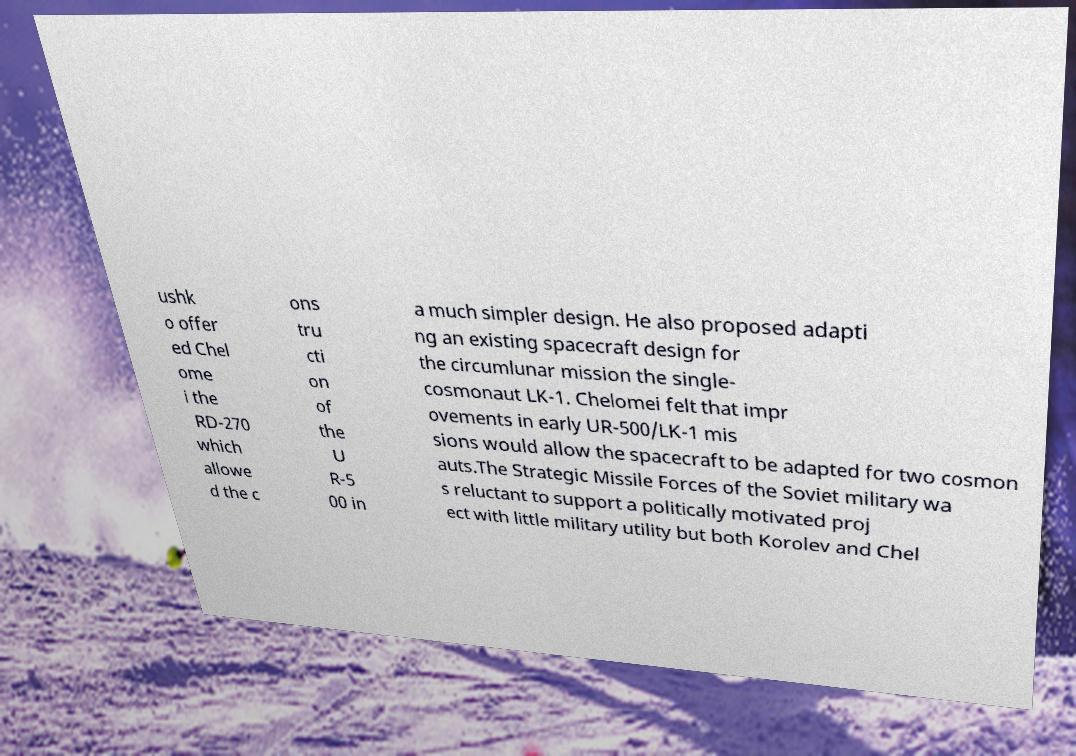Please identify and transcribe the text found in this image. ushk o offer ed Chel ome i the RD-270 which allowe d the c ons tru cti on of the U R-5 00 in a much simpler design. He also proposed adapti ng an existing spacecraft design for the circumlunar mission the single- cosmonaut LK-1. Chelomei felt that impr ovements in early UR-500/LK-1 mis sions would allow the spacecraft to be adapted for two cosmon auts.The Strategic Missile Forces of the Soviet military wa s reluctant to support a politically motivated proj ect with little military utility but both Korolev and Chel 